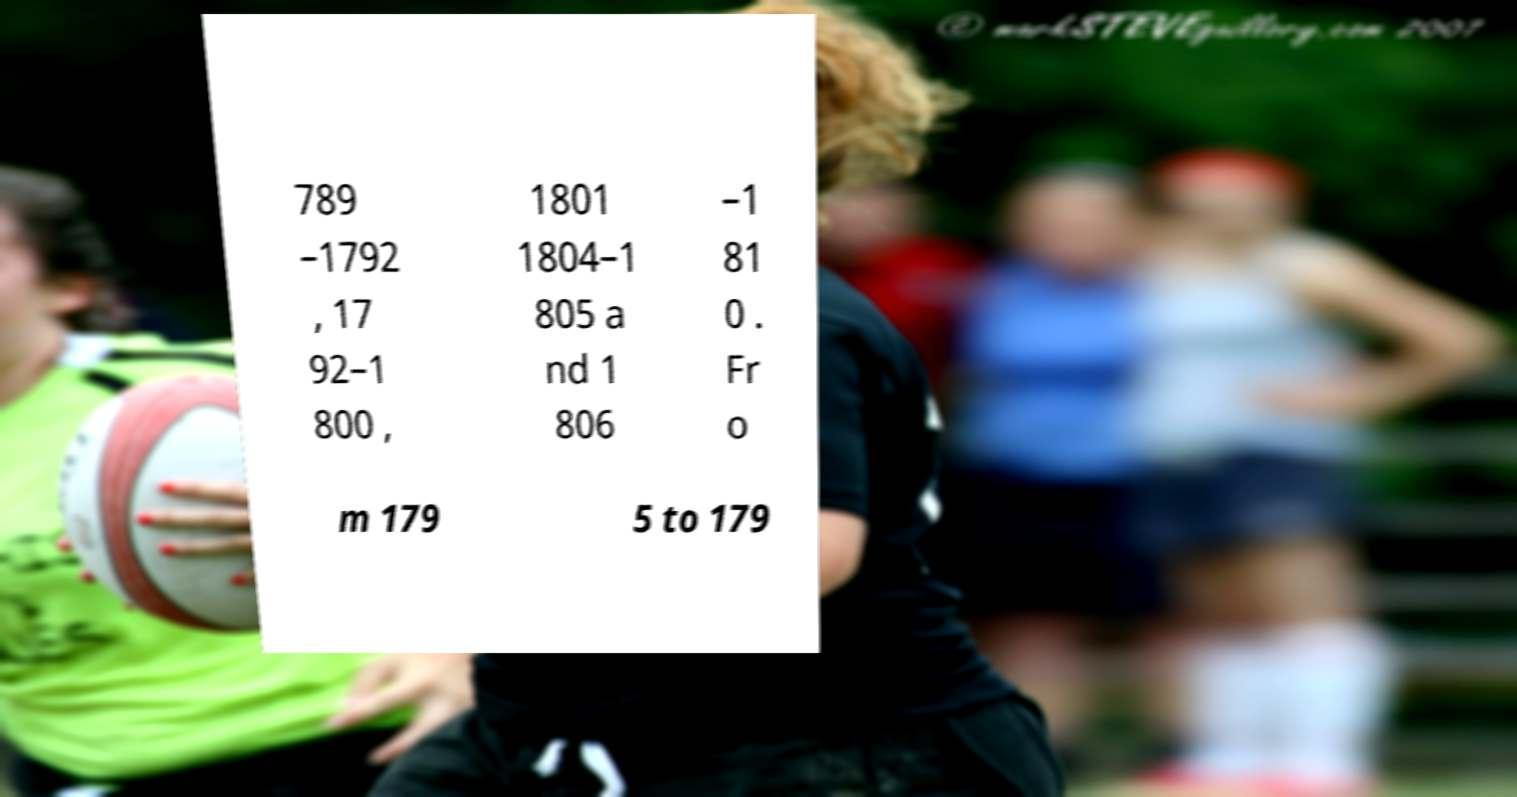There's text embedded in this image that I need extracted. Can you transcribe it verbatim? 789 –1792 , 17 92–1 800 , 1801 1804–1 805 a nd 1 806 –1 81 0 . Fr o m 179 5 to 179 